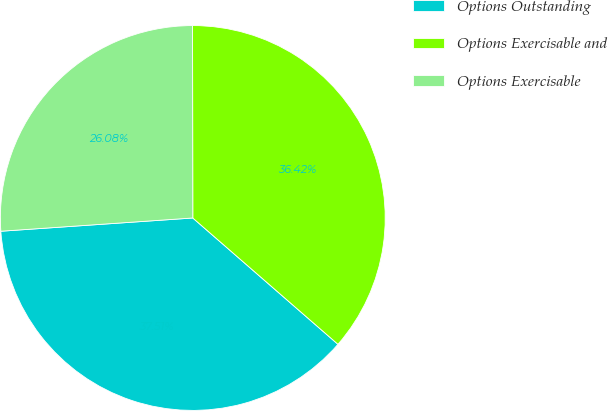Convert chart to OTSL. <chart><loc_0><loc_0><loc_500><loc_500><pie_chart><fcel>Options Outstanding<fcel>Options Exercisable and<fcel>Options Exercisable<nl><fcel>37.51%<fcel>36.42%<fcel>26.08%<nl></chart> 